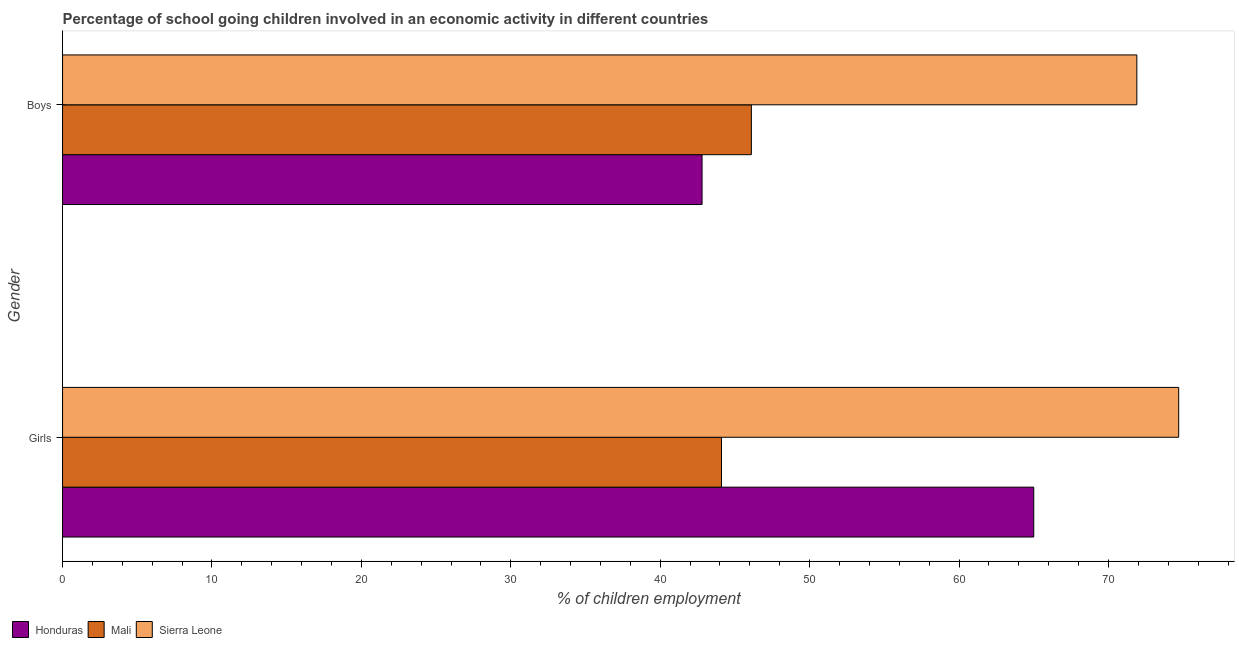How many groups of bars are there?
Provide a succinct answer. 2. Are the number of bars per tick equal to the number of legend labels?
Provide a short and direct response. Yes. How many bars are there on the 2nd tick from the top?
Provide a succinct answer. 3. What is the label of the 2nd group of bars from the top?
Make the answer very short. Girls. What is the percentage of school going boys in Honduras?
Offer a terse response. 42.8. Across all countries, what is the maximum percentage of school going girls?
Make the answer very short. 74.7. Across all countries, what is the minimum percentage of school going boys?
Your response must be concise. 42.8. In which country was the percentage of school going boys maximum?
Provide a short and direct response. Sierra Leone. In which country was the percentage of school going boys minimum?
Give a very brief answer. Honduras. What is the total percentage of school going boys in the graph?
Give a very brief answer. 160.8. What is the difference between the percentage of school going girls in Honduras and that in Sierra Leone?
Provide a short and direct response. -9.7. What is the difference between the percentage of school going girls in Honduras and the percentage of school going boys in Mali?
Give a very brief answer. 18.9. What is the average percentage of school going boys per country?
Provide a short and direct response. 53.6. What is the difference between the percentage of school going girls and percentage of school going boys in Mali?
Give a very brief answer. -2. In how many countries, is the percentage of school going boys greater than 66 %?
Make the answer very short. 1. What is the ratio of the percentage of school going girls in Mali to that in Sierra Leone?
Your answer should be compact. 0.59. Is the percentage of school going boys in Honduras less than that in Sierra Leone?
Your answer should be very brief. Yes. What does the 1st bar from the top in Girls represents?
Provide a succinct answer. Sierra Leone. What does the 3rd bar from the bottom in Boys represents?
Give a very brief answer. Sierra Leone. Are all the bars in the graph horizontal?
Give a very brief answer. Yes. What is the difference between two consecutive major ticks on the X-axis?
Make the answer very short. 10. Are the values on the major ticks of X-axis written in scientific E-notation?
Provide a succinct answer. No. Does the graph contain any zero values?
Make the answer very short. No. Does the graph contain grids?
Ensure brevity in your answer.  No. How many legend labels are there?
Ensure brevity in your answer.  3. What is the title of the graph?
Keep it short and to the point. Percentage of school going children involved in an economic activity in different countries. What is the label or title of the X-axis?
Make the answer very short. % of children employment. What is the label or title of the Y-axis?
Your answer should be compact. Gender. What is the % of children employment in Honduras in Girls?
Your answer should be compact. 65. What is the % of children employment in Mali in Girls?
Give a very brief answer. 44.1. What is the % of children employment of Sierra Leone in Girls?
Your answer should be very brief. 74.7. What is the % of children employment in Honduras in Boys?
Your answer should be compact. 42.8. What is the % of children employment in Mali in Boys?
Offer a very short reply. 46.1. What is the % of children employment in Sierra Leone in Boys?
Offer a very short reply. 71.9. Across all Gender, what is the maximum % of children employment in Honduras?
Give a very brief answer. 65. Across all Gender, what is the maximum % of children employment in Mali?
Provide a short and direct response. 46.1. Across all Gender, what is the maximum % of children employment in Sierra Leone?
Offer a terse response. 74.7. Across all Gender, what is the minimum % of children employment of Honduras?
Provide a short and direct response. 42.8. Across all Gender, what is the minimum % of children employment of Mali?
Your answer should be compact. 44.1. Across all Gender, what is the minimum % of children employment in Sierra Leone?
Your answer should be very brief. 71.9. What is the total % of children employment in Honduras in the graph?
Make the answer very short. 107.8. What is the total % of children employment in Mali in the graph?
Give a very brief answer. 90.2. What is the total % of children employment in Sierra Leone in the graph?
Provide a succinct answer. 146.6. What is the difference between the % of children employment in Mali in Girls and the % of children employment in Sierra Leone in Boys?
Provide a short and direct response. -27.8. What is the average % of children employment in Honduras per Gender?
Your answer should be compact. 53.9. What is the average % of children employment in Mali per Gender?
Your answer should be compact. 45.1. What is the average % of children employment of Sierra Leone per Gender?
Offer a terse response. 73.3. What is the difference between the % of children employment of Honduras and % of children employment of Mali in Girls?
Make the answer very short. 20.9. What is the difference between the % of children employment in Mali and % of children employment in Sierra Leone in Girls?
Offer a terse response. -30.6. What is the difference between the % of children employment in Honduras and % of children employment in Sierra Leone in Boys?
Your answer should be very brief. -29.1. What is the difference between the % of children employment in Mali and % of children employment in Sierra Leone in Boys?
Give a very brief answer. -25.8. What is the ratio of the % of children employment of Honduras in Girls to that in Boys?
Your answer should be compact. 1.52. What is the ratio of the % of children employment of Mali in Girls to that in Boys?
Provide a succinct answer. 0.96. What is the ratio of the % of children employment of Sierra Leone in Girls to that in Boys?
Your response must be concise. 1.04. What is the difference between the highest and the second highest % of children employment of Mali?
Your response must be concise. 2. What is the difference between the highest and the second highest % of children employment in Sierra Leone?
Make the answer very short. 2.8. What is the difference between the highest and the lowest % of children employment of Sierra Leone?
Your response must be concise. 2.8. 